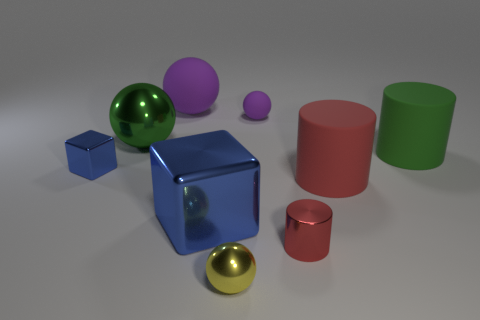Subtract all red cylinders. How many cylinders are left? 1 Subtract all purple balls. How many red cylinders are left? 2 Subtract 2 spheres. How many spheres are left? 2 Add 1 tiny red shiny spheres. How many objects exist? 10 Subtract all green spheres. How many spheres are left? 3 Subtract all blocks. How many objects are left? 7 Add 6 big red matte objects. How many big red matte objects exist? 7 Subtract 0 blue spheres. How many objects are left? 9 Subtract all brown cubes. Subtract all yellow cylinders. How many cubes are left? 2 Subtract all big balls. Subtract all big green shiny balls. How many objects are left? 6 